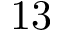Convert formula to latex. <formula><loc_0><loc_0><loc_500><loc_500>1 3</formula> 